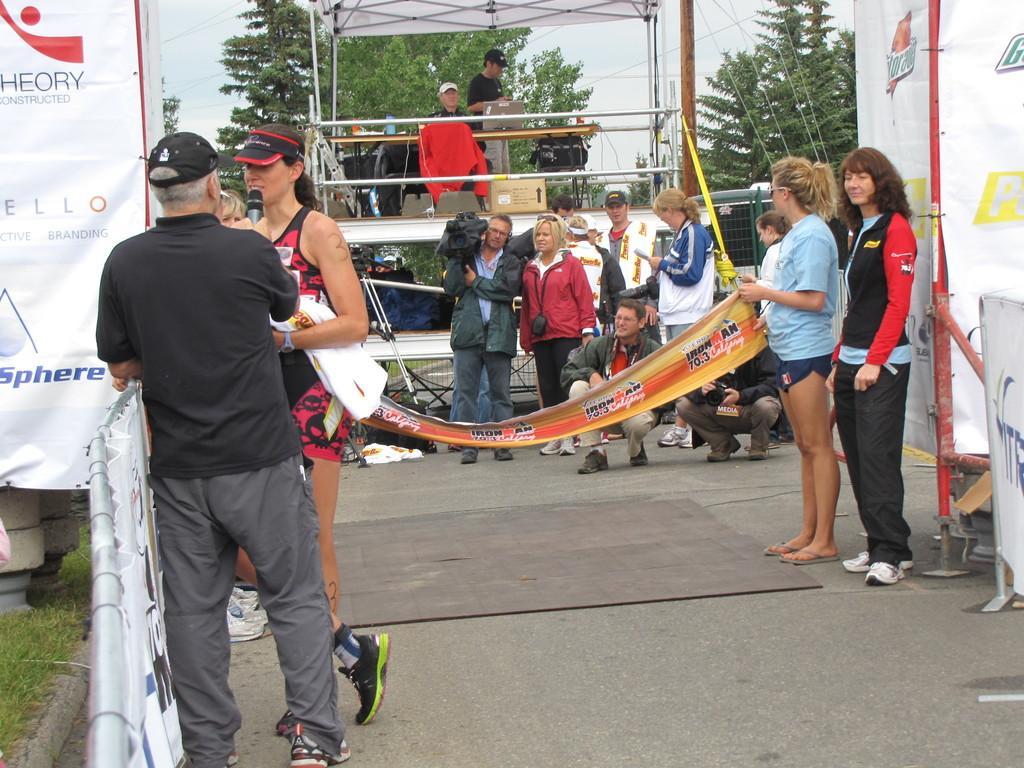Describe this image in one or two sentences. In this image I can see a road, on the road I can see a stand , on stand i can see persons , top of stand there is a tent , in front of stand there is a camera man holding camera and few persons standing , few persons sitting in squat position, one person holding a banner , there is a woman standing in front of banner on the right side,there is a hoarding board visible on the left side in front of the hoarding board there is a fence , in front of fence a person holding a mike and a woman standing in front of person,in the background there are some trees and the sky and power line cables visible. 